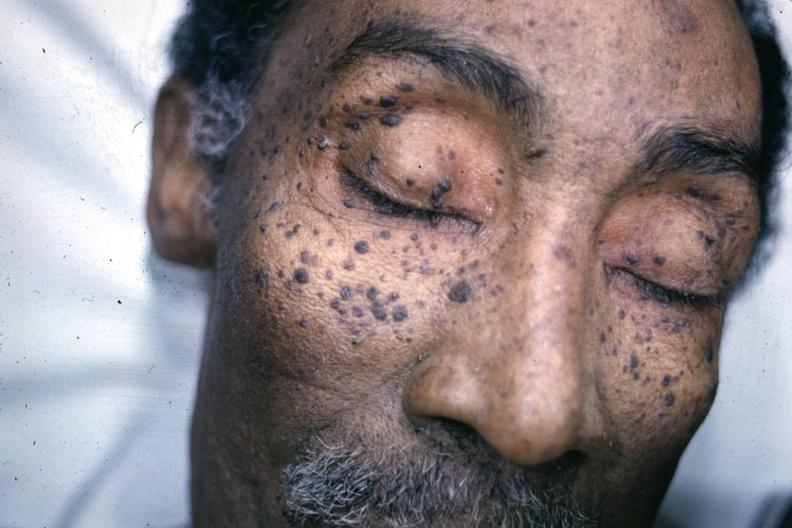how does this image show photo of face?
Answer the question using a single word or phrase. With multiple typical lesions 